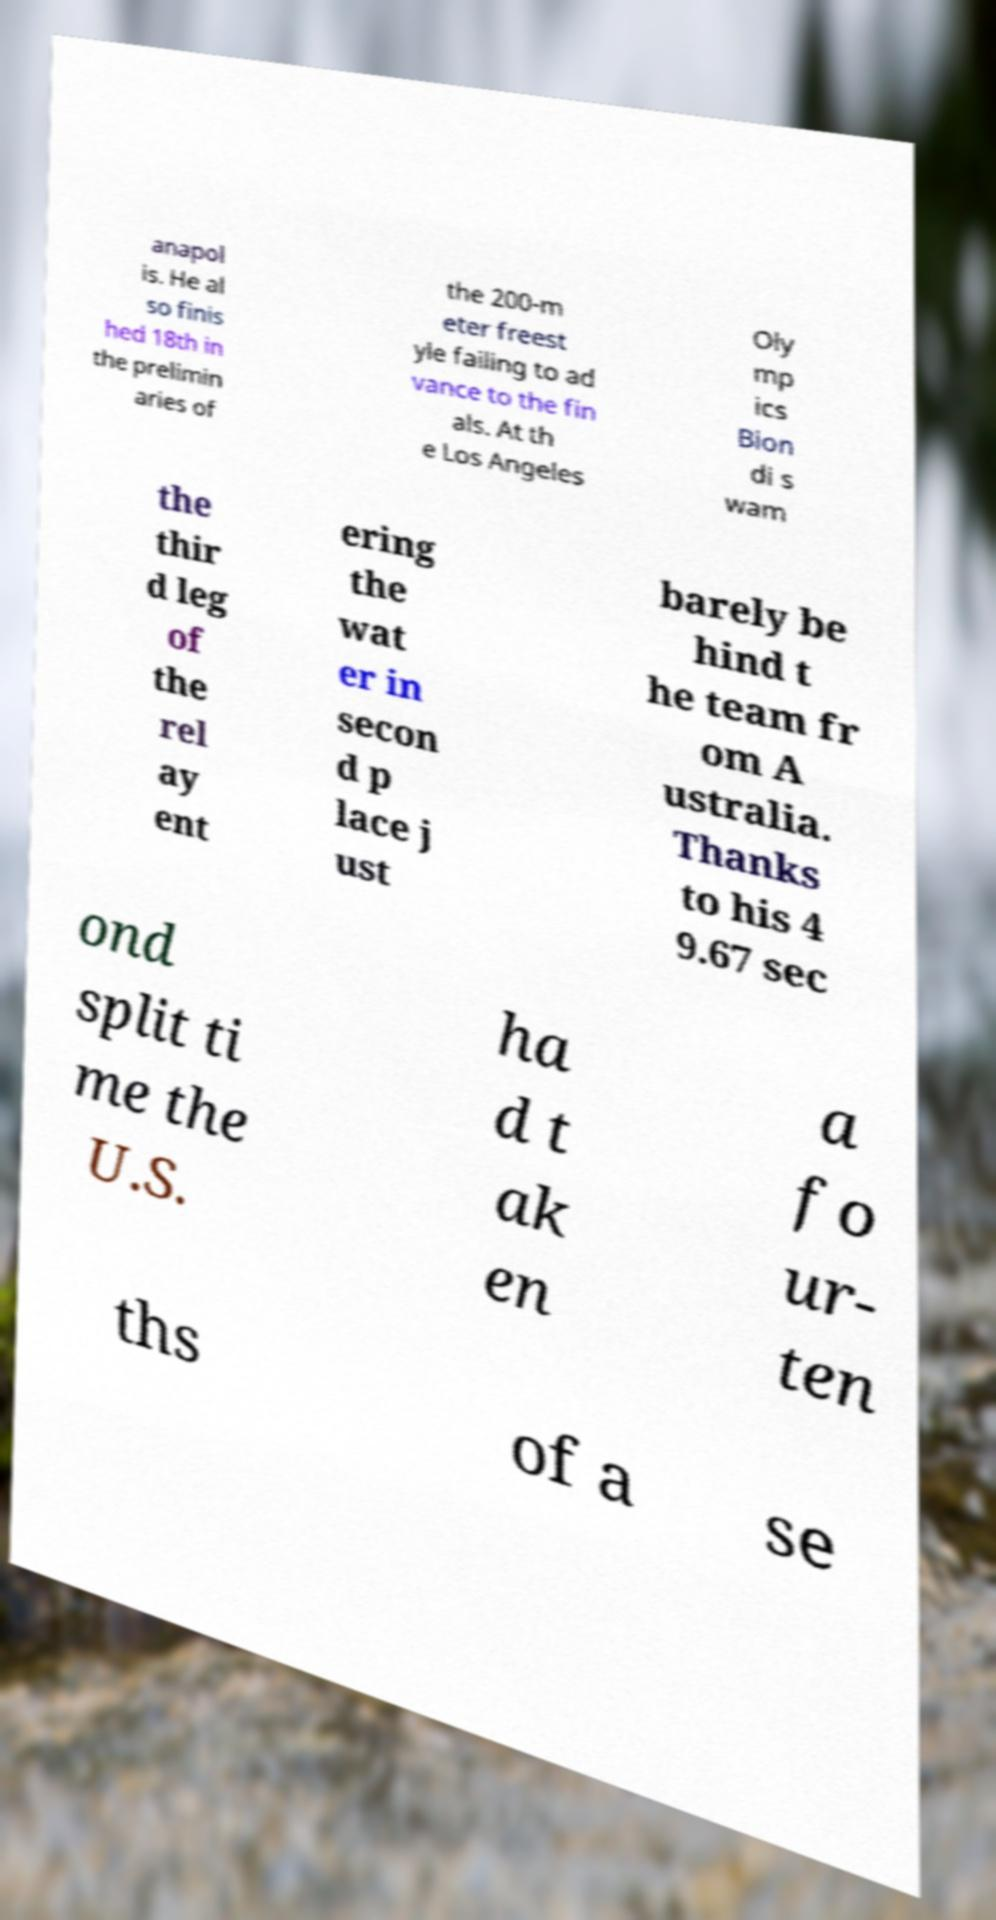Please read and relay the text visible in this image. What does it say? anapol is. He al so finis hed 18th in the prelimin aries of the 200-m eter freest yle failing to ad vance to the fin als. At th e Los Angeles Oly mp ics Bion di s wam the thir d leg of the rel ay ent ering the wat er in secon d p lace j ust barely be hind t he team fr om A ustralia. Thanks to his 4 9.67 sec ond split ti me the U.S. ha d t ak en a fo ur- ten ths of a se 